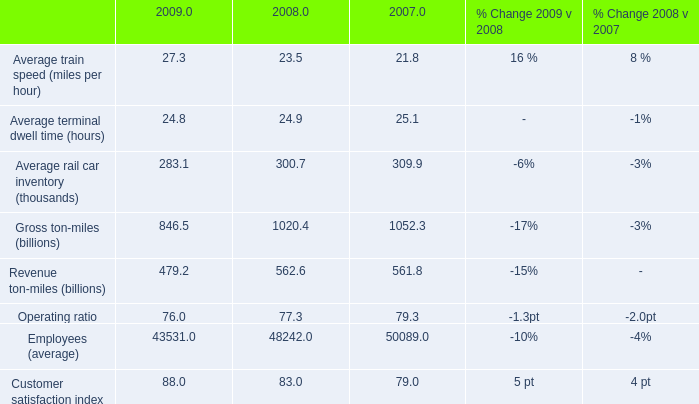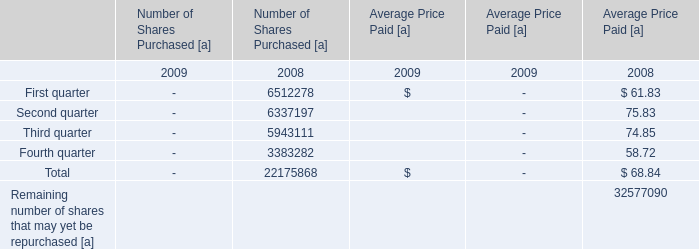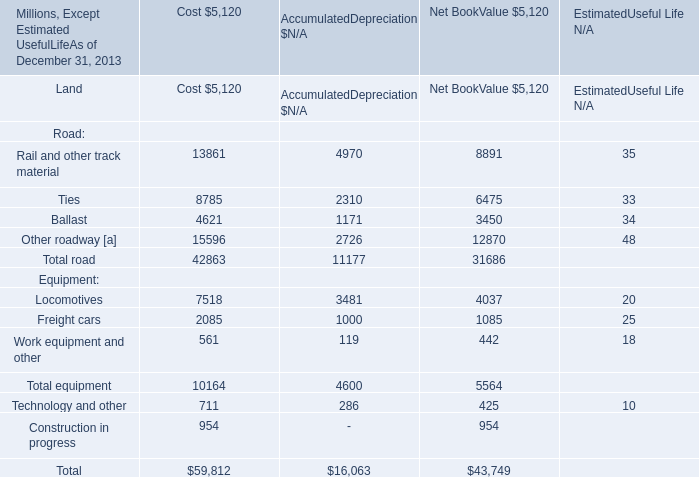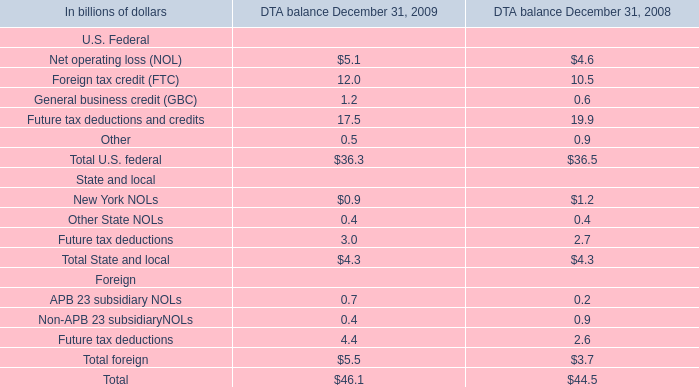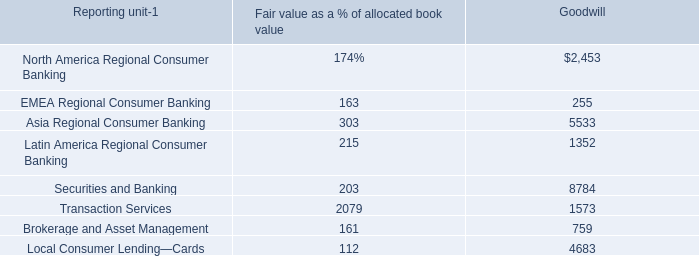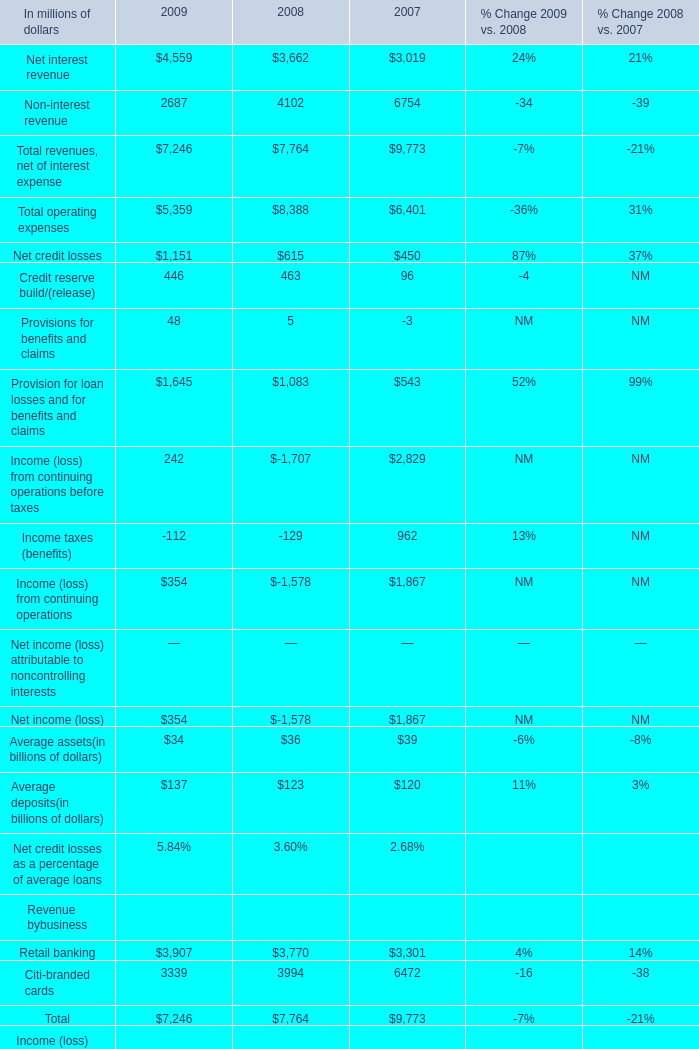what will 2010 operating ratio be if the average 2009 and 2008 increases occur in 2009? 
Computations: (76.0 + ((1.3 + 2) / 2))
Answer: 77.65. 